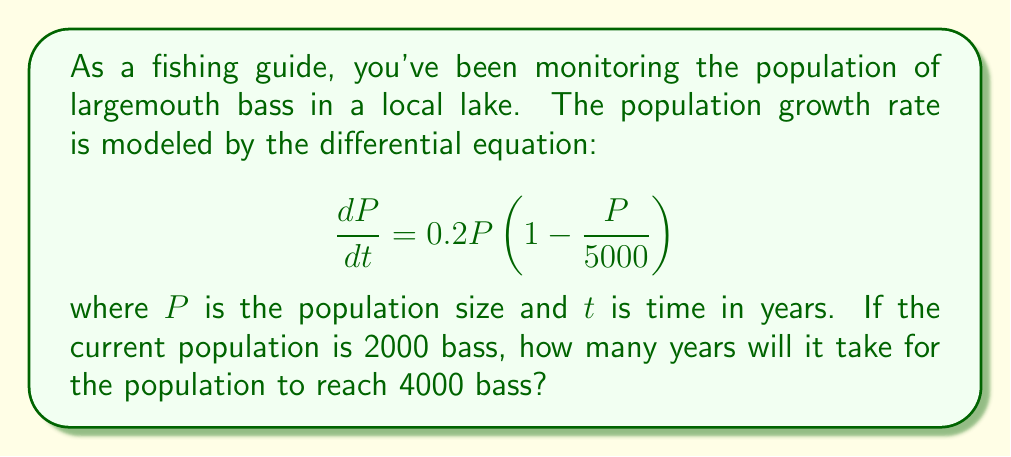Give your solution to this math problem. To solve this problem, we need to use the logistic growth model and integrate the differential equation. Let's approach this step-by-step:

1) The given differential equation is a logistic growth model with:
   - Intrinsic growth rate $r = 0.2$
   - Carrying capacity $K = 5000$

2) The general solution for the logistic growth model is:

   $$P(t) = \frac{K}{1 + \left(\frac{K}{P_0} - 1\right)e^{-rt}}$$

   where $P_0$ is the initial population.

3) Substituting the known values:
   
   $$P(t) = \frac{5000}{1 + \left(\frac{5000}{2000} - 1\right)e^{-0.2t}}$$

4) We want to find $t$ when $P(t) = 4000$. Let's substitute this:

   $$4000 = \frac{5000}{1 + \left(\frac{5000}{2000} - 1\right)e^{-0.2t}}$$

5) Solving for $t$:

   $$1 + \left(\frac{5000}{2000} - 1\right)e^{-0.2t} = \frac{5000}{4000}$$

   $$\left(\frac{5000}{2000} - 1\right)e^{-0.2t} = \frac{5000}{4000} - 1$$

   $$e^{-0.2t} = \frac{\frac{5000}{4000} - 1}{\frac{5000}{2000} - 1} = \frac{0.25}{1.5} = \frac{1}{6}$$

6) Taking the natural log of both sides:

   $$-0.2t = \ln\left(\frac{1}{6}\right)$$

   $$t = -\frac{\ln\left(\frac{1}{6}\right)}{0.2} \approx 8.95$$

Therefore, it will take approximately 8.95 years for the population to reach 4000 bass.
Answer: 8.95 years 